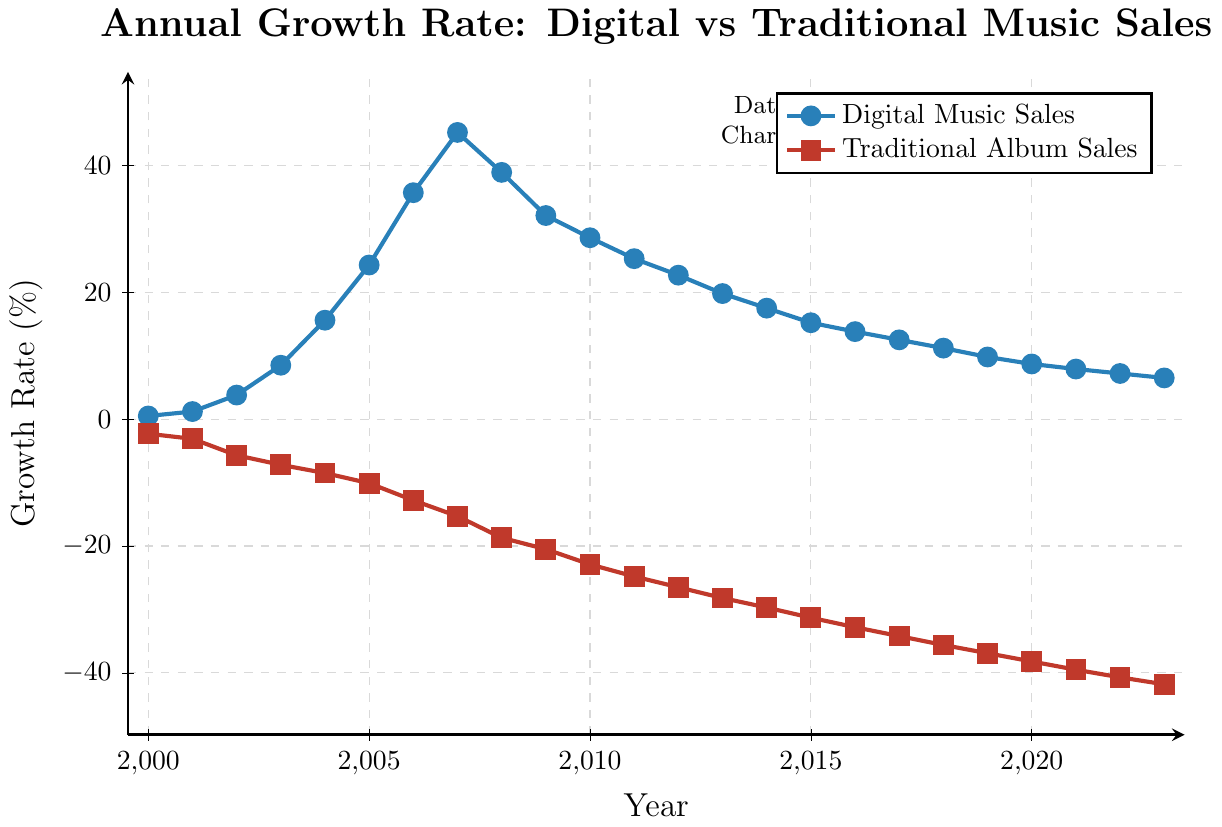What is the maximum growth rate of digital music sales and in which year was it observed? The maximum growth rate of digital music sales can be observed at the highest point on the line representing digital music sales. The highest value is 45.2% in 2007.
Answer: 45.2%, 2007 What is the trend in the growth rate of traditional album sales from 2010 to 2023? To identify the trend, track the values from 2010 to 2023. The growth rate declines from -22.9% in 2010 to -41.8% in 2023. This indicates a consistent negative growth trend.
Answer: Consistent decline from -22.9% to -41.8% Which year had the largest difference between the growth rates of digital music sales and traditional album sales? Calculate the difference for each year by subtracting the traditional album sales growth rate from the digital music sales growth rate. The largest difference is observed in 2007, where the difference is 45.2% - (-15.3%) = 60.5%.
Answer: 2007 How did the growth rate of digital music sales change between 2003 and 2004? Compare the growth rate values in 2003 and 2004. The values are 8.5% in 2003 and 15.6% in 2004. Subtract 8.5 from 15.6 to find the change.
Answer: Increased by 7.1% In which year did the growth rate for digital music sales drop for the first time, and by how much did it drop? Look for the first decrease in the values of digital music sales growth rates. The growth rate dropped for the first time between 2007 and 2008, from 45.2% to 38.9%. Calculate the drop by subtracting 38.9 from 45.2.
Answer: 2008, dropped by 6.3% Is there any year where the growth rates of digital music sales and traditional album sales have the same absolute value? Compare the absolute values of growth rates of the two sales types for each year. In 2011, the growth rate of digital music sales is 25.3% and traditional album sales is -24.8%; the values are nearly the same but not exactly. In 2018, digital music sales growth rate is 11.2% and traditional album sales growth rate is -35.6%; hence, no year has identical absolute values based on the chart.
Answer: No What is the average annual growth rate of traditional album sales from 2000 to 2023? Sum the growth rates from 2000 to 2023 for traditional album sales and divide by the number of years (24). The sum is: -2.3 - 3.1 - 5.7 - 7.2 - 8.5 - 10.1 - 12.8 - 15.3 - 18.7 - 20.5 - 22.9 - 24.8 - 26.5 - 28.2 - 29.7 - 31.3 - 32.8 - 34.2 - 35.6 - 36.9 - 38.2 - 39.5 - 40.7 - 41.8 = -570.4. The average is -570.4 / 24.
Answer: -23.77% Between which two consecutive years did digital music sales experience the highest increase in growth rate? Calculate the differences in growth rates between consecutive years and identify the highest increase. Between 2006 to 2007, the growth rate increased from 35.7% to 45.2%, an increase of 9.5%, which is the highest.
Answer: 2006 and 2007 